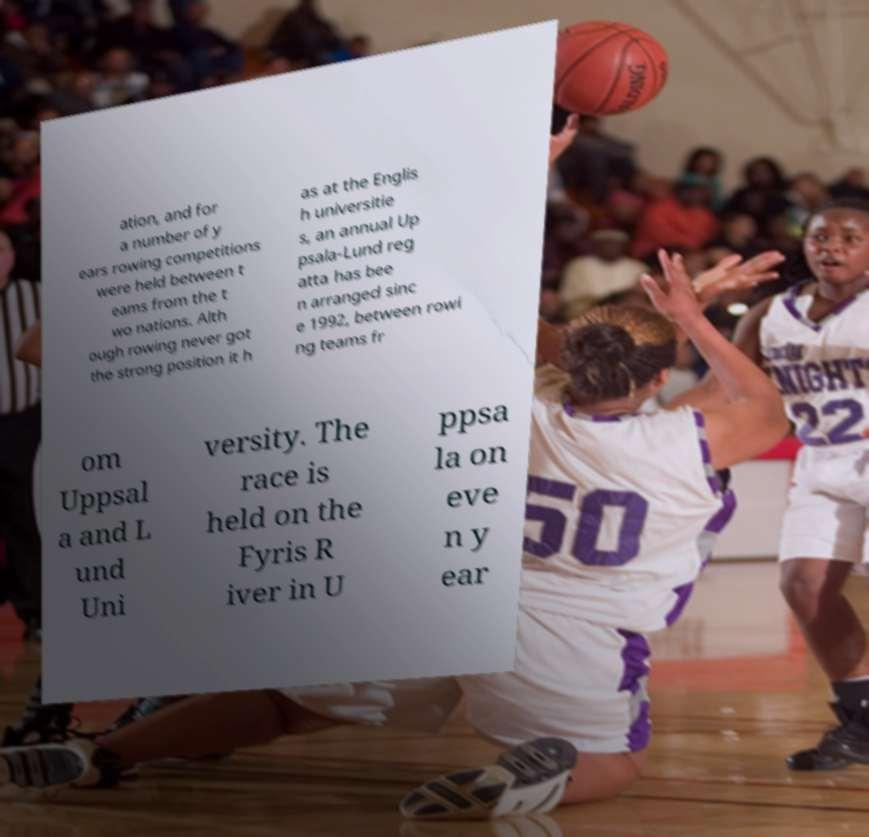What messages or text are displayed in this image? I need them in a readable, typed format. ation, and for a number of y ears rowing competitions were held between t eams from the t wo nations. Alth ough rowing never got the strong position it h as at the Englis h universitie s, an annual Up psala-Lund reg atta has bee n arranged sinc e 1992, between rowi ng teams fr om Uppsal a and L und Uni versity. The race is held on the Fyris R iver in U ppsa la on eve n y ear 